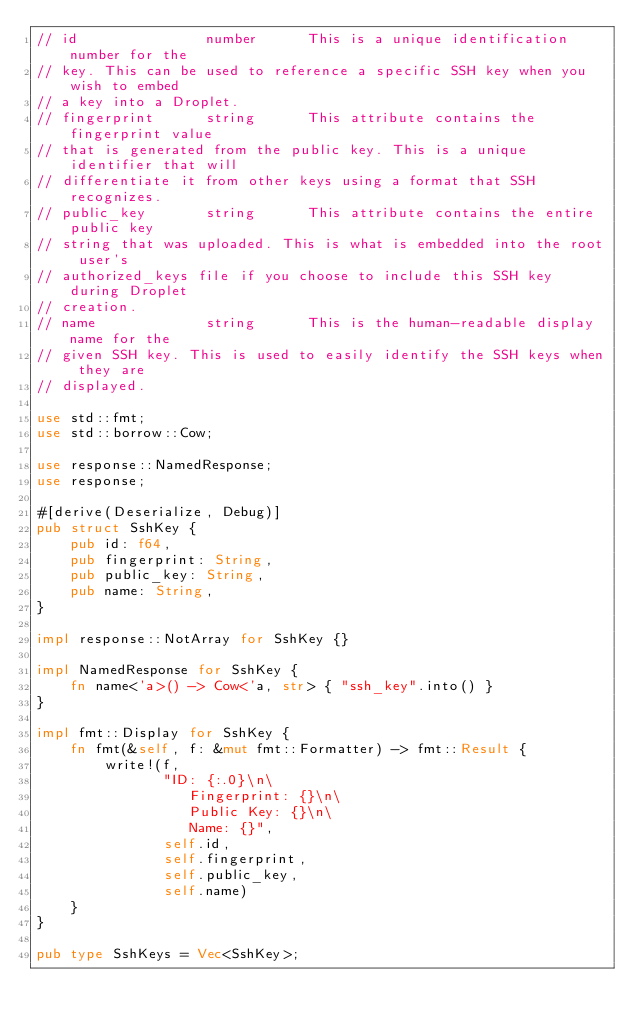<code> <loc_0><loc_0><loc_500><loc_500><_Rust_>// id               number      This is a unique identification number for the
// key. This can be used to reference a specific SSH key when you wish to embed
// a key into a Droplet.
// fingerprint      string      This attribute contains the fingerprint value
// that is generated from the public key. This is a unique identifier that will
// differentiate it from other keys using a format that SSH recognizes.
// public_key       string      This attribute contains the entire public key
// string that was uploaded. This is what is embedded into the root user's
// authorized_keys file if you choose to include this SSH key during Droplet
// creation.
// name             string      This is the human-readable display name for the
// given SSH key. This is used to easily identify the SSH keys when they are
// displayed.

use std::fmt;
use std::borrow::Cow;

use response::NamedResponse;
use response;

#[derive(Deserialize, Debug)]
pub struct SshKey {
    pub id: f64,
    pub fingerprint: String,
    pub public_key: String,
    pub name: String,
}

impl response::NotArray for SshKey {}

impl NamedResponse for SshKey {
    fn name<'a>() -> Cow<'a, str> { "ssh_key".into() }
}

impl fmt::Display for SshKey {
    fn fmt(&self, f: &mut fmt::Formatter) -> fmt::Result {
        write!(f,
               "ID: {:.0}\n\
                  Fingerprint: {}\n\
                  Public Key: {}\n\
                  Name: {}",
               self.id,
               self.fingerprint,
               self.public_key,
               self.name)
    }
}

pub type SshKeys = Vec<SshKey>;
</code> 